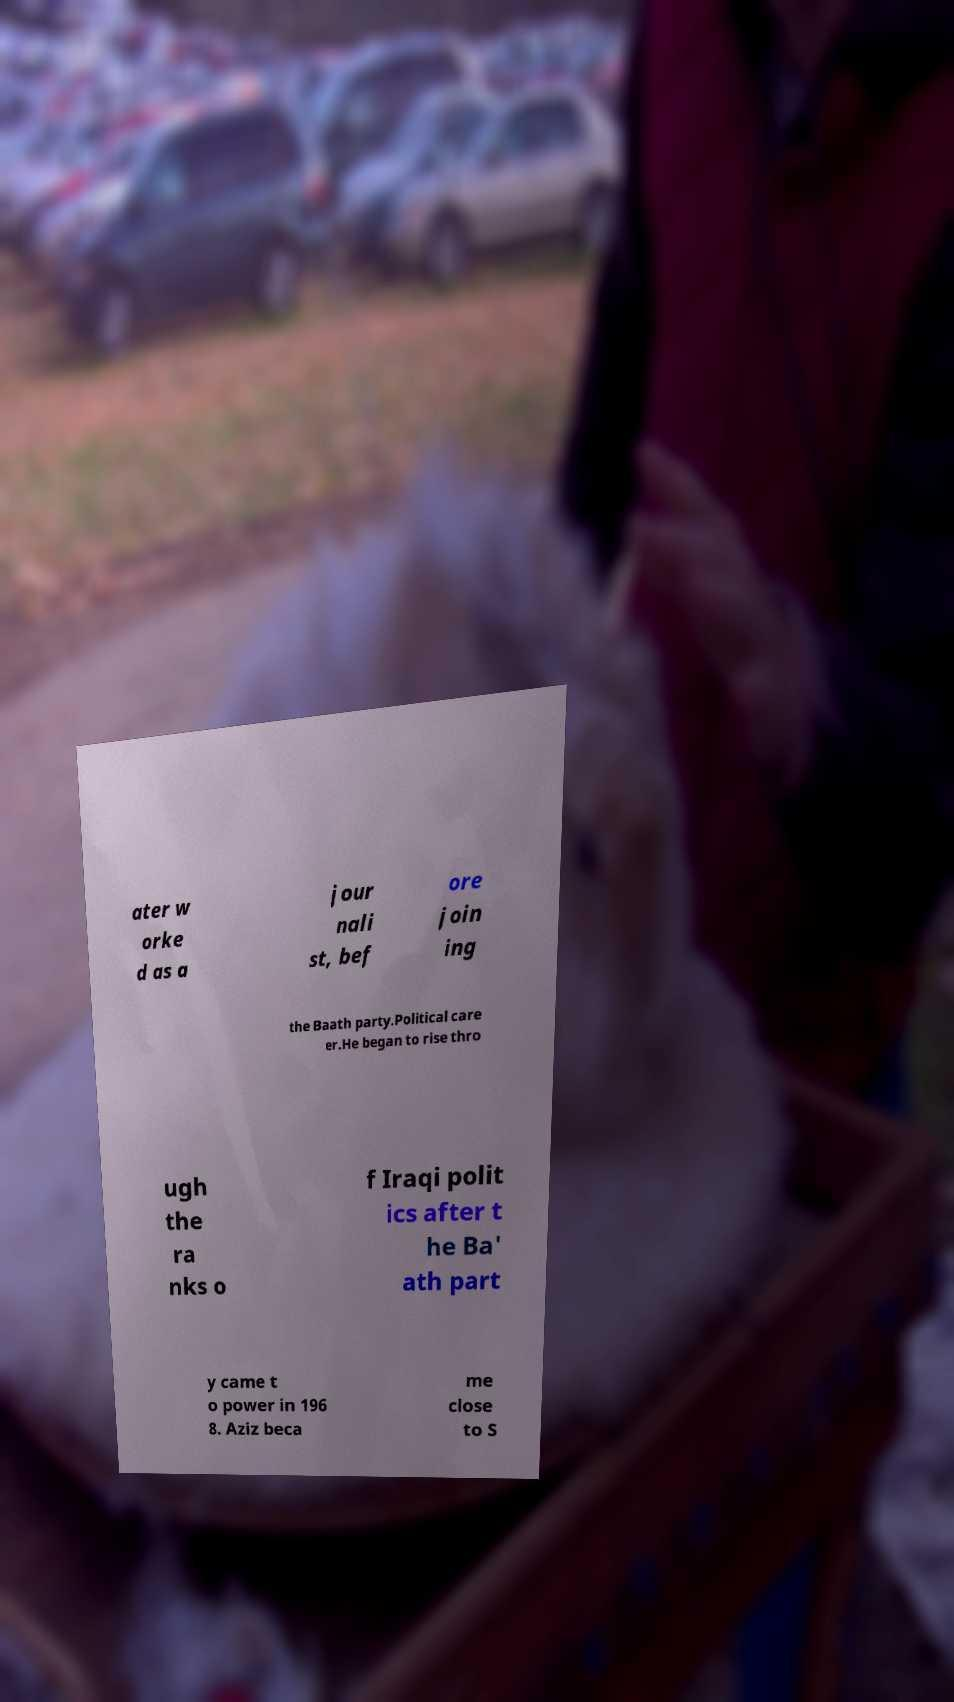I need the written content from this picture converted into text. Can you do that? ater w orke d as a jour nali st, bef ore join ing the Baath party.Political care er.He began to rise thro ugh the ra nks o f Iraqi polit ics after t he Ba' ath part y came t o power in 196 8. Aziz beca me close to S 